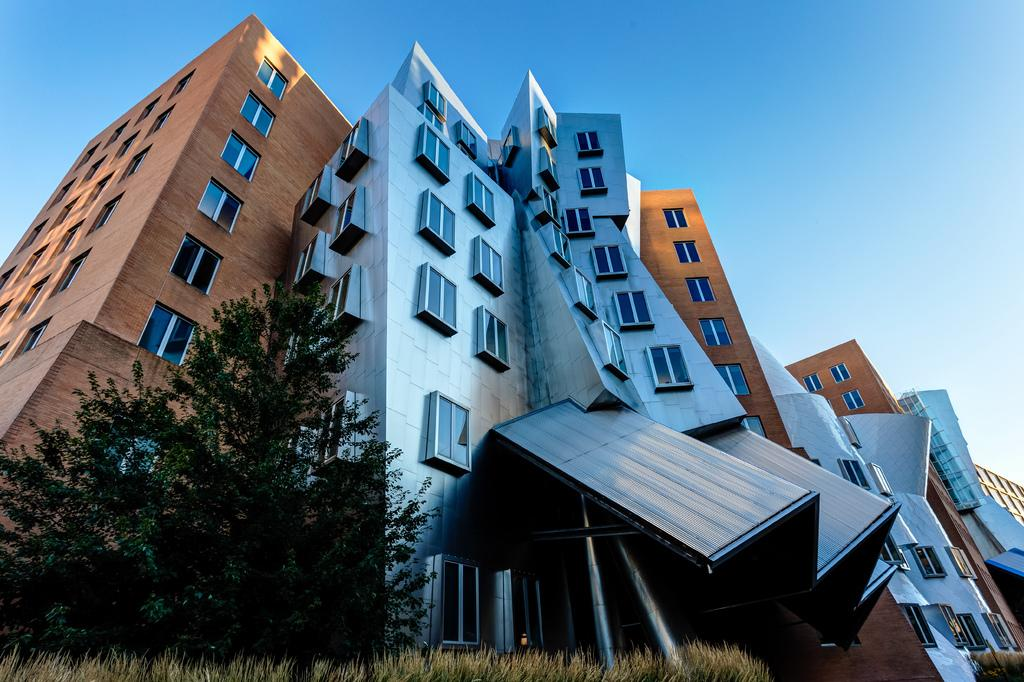What type of structures are present in the image? There are buildings in the image. What feature do the buildings have? The buildings have windows. What type of vegetation is present in the image? There is a tree and grass plants in the image. What part of the natural environment is visible in the image? The sky is visible in the image. What riddle is written on the calendar in the image? There is no calendar present in the image, so no riddle can be observed. What type of farm animals can be seen grazing in the image? There is no farm or farm animals present in the image. 